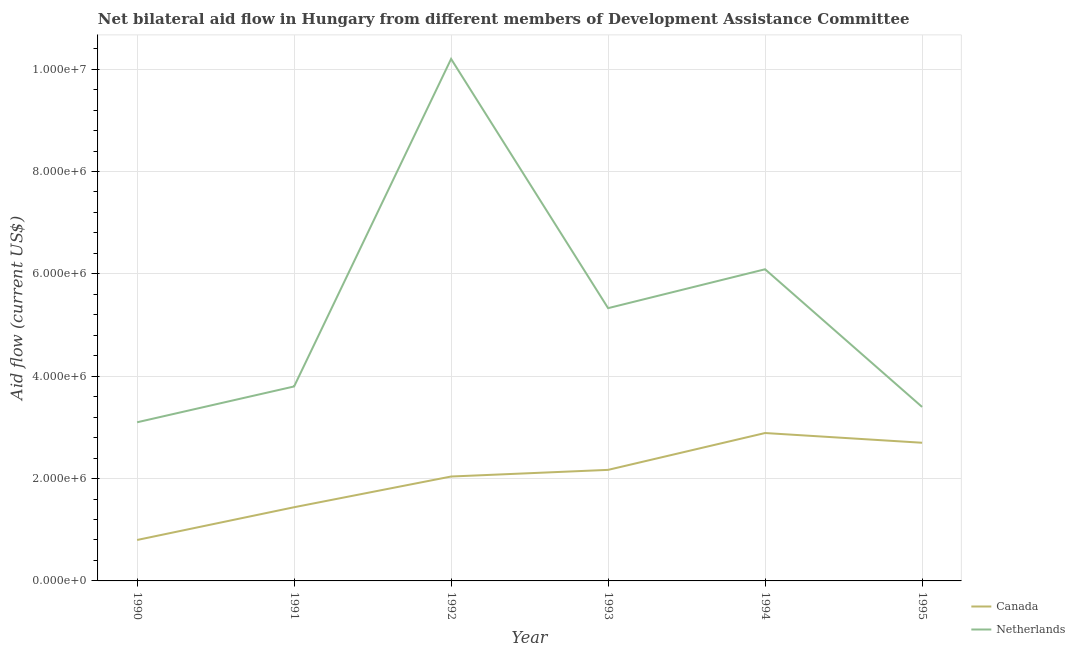How many different coloured lines are there?
Provide a succinct answer. 2. Does the line corresponding to amount of aid given by netherlands intersect with the line corresponding to amount of aid given by canada?
Your answer should be compact. No. Is the number of lines equal to the number of legend labels?
Your answer should be very brief. Yes. What is the amount of aid given by canada in 1995?
Your answer should be compact. 2.70e+06. Across all years, what is the maximum amount of aid given by netherlands?
Provide a succinct answer. 1.02e+07. Across all years, what is the minimum amount of aid given by canada?
Provide a short and direct response. 8.00e+05. In which year was the amount of aid given by canada minimum?
Your answer should be compact. 1990. What is the total amount of aid given by canada in the graph?
Offer a very short reply. 1.20e+07. What is the difference between the amount of aid given by netherlands in 1993 and that in 1994?
Offer a terse response. -7.60e+05. What is the difference between the amount of aid given by canada in 1994 and the amount of aid given by netherlands in 1990?
Keep it short and to the point. -2.10e+05. What is the average amount of aid given by netherlands per year?
Your answer should be very brief. 5.32e+06. In the year 1993, what is the difference between the amount of aid given by netherlands and amount of aid given by canada?
Give a very brief answer. 3.16e+06. What is the ratio of the amount of aid given by canada in 1991 to that in 1995?
Offer a very short reply. 0.53. Is the amount of aid given by canada in 1991 less than that in 1992?
Your response must be concise. Yes. Is the difference between the amount of aid given by canada in 1994 and 1995 greater than the difference between the amount of aid given by netherlands in 1994 and 1995?
Give a very brief answer. No. What is the difference between the highest and the second highest amount of aid given by canada?
Offer a terse response. 1.90e+05. What is the difference between the highest and the lowest amount of aid given by netherlands?
Make the answer very short. 7.10e+06. In how many years, is the amount of aid given by netherlands greater than the average amount of aid given by netherlands taken over all years?
Your answer should be compact. 3. Does the amount of aid given by netherlands monotonically increase over the years?
Ensure brevity in your answer.  No. How many years are there in the graph?
Your response must be concise. 6. Are the values on the major ticks of Y-axis written in scientific E-notation?
Provide a short and direct response. Yes. Where does the legend appear in the graph?
Your answer should be very brief. Bottom right. How are the legend labels stacked?
Make the answer very short. Vertical. What is the title of the graph?
Ensure brevity in your answer.  Net bilateral aid flow in Hungary from different members of Development Assistance Committee. What is the label or title of the Y-axis?
Offer a terse response. Aid flow (current US$). What is the Aid flow (current US$) of Netherlands in 1990?
Your answer should be very brief. 3.10e+06. What is the Aid flow (current US$) of Canada in 1991?
Ensure brevity in your answer.  1.44e+06. What is the Aid flow (current US$) of Netherlands in 1991?
Your answer should be very brief. 3.80e+06. What is the Aid flow (current US$) in Canada in 1992?
Provide a short and direct response. 2.04e+06. What is the Aid flow (current US$) of Netherlands in 1992?
Your answer should be very brief. 1.02e+07. What is the Aid flow (current US$) in Canada in 1993?
Your answer should be compact. 2.17e+06. What is the Aid flow (current US$) in Netherlands in 1993?
Offer a very short reply. 5.33e+06. What is the Aid flow (current US$) in Canada in 1994?
Offer a very short reply. 2.89e+06. What is the Aid flow (current US$) of Netherlands in 1994?
Provide a succinct answer. 6.09e+06. What is the Aid flow (current US$) of Canada in 1995?
Provide a succinct answer. 2.70e+06. What is the Aid flow (current US$) in Netherlands in 1995?
Your answer should be compact. 3.40e+06. Across all years, what is the maximum Aid flow (current US$) of Canada?
Give a very brief answer. 2.89e+06. Across all years, what is the maximum Aid flow (current US$) of Netherlands?
Your answer should be very brief. 1.02e+07. Across all years, what is the minimum Aid flow (current US$) of Netherlands?
Offer a terse response. 3.10e+06. What is the total Aid flow (current US$) of Canada in the graph?
Give a very brief answer. 1.20e+07. What is the total Aid flow (current US$) in Netherlands in the graph?
Your answer should be very brief. 3.19e+07. What is the difference between the Aid flow (current US$) in Canada in 1990 and that in 1991?
Provide a succinct answer. -6.40e+05. What is the difference between the Aid flow (current US$) of Netherlands in 1990 and that in 1991?
Provide a short and direct response. -7.00e+05. What is the difference between the Aid flow (current US$) of Canada in 1990 and that in 1992?
Provide a short and direct response. -1.24e+06. What is the difference between the Aid flow (current US$) in Netherlands in 1990 and that in 1992?
Ensure brevity in your answer.  -7.10e+06. What is the difference between the Aid flow (current US$) in Canada in 1990 and that in 1993?
Your response must be concise. -1.37e+06. What is the difference between the Aid flow (current US$) of Netherlands in 1990 and that in 1993?
Your answer should be compact. -2.23e+06. What is the difference between the Aid flow (current US$) in Canada in 1990 and that in 1994?
Your answer should be very brief. -2.09e+06. What is the difference between the Aid flow (current US$) in Netherlands in 1990 and that in 1994?
Provide a succinct answer. -2.99e+06. What is the difference between the Aid flow (current US$) of Canada in 1990 and that in 1995?
Offer a very short reply. -1.90e+06. What is the difference between the Aid flow (current US$) in Canada in 1991 and that in 1992?
Your answer should be very brief. -6.00e+05. What is the difference between the Aid flow (current US$) of Netherlands in 1991 and that in 1992?
Your answer should be very brief. -6.40e+06. What is the difference between the Aid flow (current US$) in Canada in 1991 and that in 1993?
Keep it short and to the point. -7.30e+05. What is the difference between the Aid flow (current US$) of Netherlands in 1991 and that in 1993?
Offer a terse response. -1.53e+06. What is the difference between the Aid flow (current US$) in Canada in 1991 and that in 1994?
Keep it short and to the point. -1.45e+06. What is the difference between the Aid flow (current US$) in Netherlands in 1991 and that in 1994?
Keep it short and to the point. -2.29e+06. What is the difference between the Aid flow (current US$) in Canada in 1991 and that in 1995?
Your answer should be compact. -1.26e+06. What is the difference between the Aid flow (current US$) of Netherlands in 1992 and that in 1993?
Provide a short and direct response. 4.87e+06. What is the difference between the Aid flow (current US$) of Canada in 1992 and that in 1994?
Provide a short and direct response. -8.50e+05. What is the difference between the Aid flow (current US$) of Netherlands in 1992 and that in 1994?
Your answer should be very brief. 4.11e+06. What is the difference between the Aid flow (current US$) of Canada in 1992 and that in 1995?
Keep it short and to the point. -6.60e+05. What is the difference between the Aid flow (current US$) in Netherlands in 1992 and that in 1995?
Offer a terse response. 6.80e+06. What is the difference between the Aid flow (current US$) of Canada in 1993 and that in 1994?
Provide a succinct answer. -7.20e+05. What is the difference between the Aid flow (current US$) in Netherlands in 1993 and that in 1994?
Ensure brevity in your answer.  -7.60e+05. What is the difference between the Aid flow (current US$) in Canada in 1993 and that in 1995?
Your answer should be compact. -5.30e+05. What is the difference between the Aid flow (current US$) in Netherlands in 1993 and that in 1995?
Provide a short and direct response. 1.93e+06. What is the difference between the Aid flow (current US$) of Canada in 1994 and that in 1995?
Provide a short and direct response. 1.90e+05. What is the difference between the Aid flow (current US$) in Netherlands in 1994 and that in 1995?
Ensure brevity in your answer.  2.69e+06. What is the difference between the Aid flow (current US$) of Canada in 1990 and the Aid flow (current US$) of Netherlands in 1992?
Provide a short and direct response. -9.40e+06. What is the difference between the Aid flow (current US$) of Canada in 1990 and the Aid flow (current US$) of Netherlands in 1993?
Provide a succinct answer. -4.53e+06. What is the difference between the Aid flow (current US$) in Canada in 1990 and the Aid flow (current US$) in Netherlands in 1994?
Your answer should be compact. -5.29e+06. What is the difference between the Aid flow (current US$) in Canada in 1990 and the Aid flow (current US$) in Netherlands in 1995?
Provide a short and direct response. -2.60e+06. What is the difference between the Aid flow (current US$) of Canada in 1991 and the Aid flow (current US$) of Netherlands in 1992?
Your answer should be compact. -8.76e+06. What is the difference between the Aid flow (current US$) of Canada in 1991 and the Aid flow (current US$) of Netherlands in 1993?
Make the answer very short. -3.89e+06. What is the difference between the Aid flow (current US$) of Canada in 1991 and the Aid flow (current US$) of Netherlands in 1994?
Your answer should be very brief. -4.65e+06. What is the difference between the Aid flow (current US$) of Canada in 1991 and the Aid flow (current US$) of Netherlands in 1995?
Ensure brevity in your answer.  -1.96e+06. What is the difference between the Aid flow (current US$) in Canada in 1992 and the Aid flow (current US$) in Netherlands in 1993?
Ensure brevity in your answer.  -3.29e+06. What is the difference between the Aid flow (current US$) of Canada in 1992 and the Aid flow (current US$) of Netherlands in 1994?
Provide a short and direct response. -4.05e+06. What is the difference between the Aid flow (current US$) in Canada in 1992 and the Aid flow (current US$) in Netherlands in 1995?
Ensure brevity in your answer.  -1.36e+06. What is the difference between the Aid flow (current US$) in Canada in 1993 and the Aid flow (current US$) in Netherlands in 1994?
Provide a short and direct response. -3.92e+06. What is the difference between the Aid flow (current US$) in Canada in 1993 and the Aid flow (current US$) in Netherlands in 1995?
Your answer should be compact. -1.23e+06. What is the difference between the Aid flow (current US$) of Canada in 1994 and the Aid flow (current US$) of Netherlands in 1995?
Your answer should be very brief. -5.10e+05. What is the average Aid flow (current US$) of Canada per year?
Your answer should be very brief. 2.01e+06. What is the average Aid flow (current US$) in Netherlands per year?
Make the answer very short. 5.32e+06. In the year 1990, what is the difference between the Aid flow (current US$) in Canada and Aid flow (current US$) in Netherlands?
Keep it short and to the point. -2.30e+06. In the year 1991, what is the difference between the Aid flow (current US$) in Canada and Aid flow (current US$) in Netherlands?
Keep it short and to the point. -2.36e+06. In the year 1992, what is the difference between the Aid flow (current US$) in Canada and Aid flow (current US$) in Netherlands?
Offer a terse response. -8.16e+06. In the year 1993, what is the difference between the Aid flow (current US$) of Canada and Aid flow (current US$) of Netherlands?
Provide a succinct answer. -3.16e+06. In the year 1994, what is the difference between the Aid flow (current US$) in Canada and Aid flow (current US$) in Netherlands?
Provide a succinct answer. -3.20e+06. In the year 1995, what is the difference between the Aid flow (current US$) of Canada and Aid flow (current US$) of Netherlands?
Offer a very short reply. -7.00e+05. What is the ratio of the Aid flow (current US$) in Canada in 1990 to that in 1991?
Your answer should be compact. 0.56. What is the ratio of the Aid flow (current US$) in Netherlands in 1990 to that in 1991?
Provide a short and direct response. 0.82. What is the ratio of the Aid flow (current US$) of Canada in 1990 to that in 1992?
Provide a short and direct response. 0.39. What is the ratio of the Aid flow (current US$) in Netherlands in 1990 to that in 1992?
Offer a very short reply. 0.3. What is the ratio of the Aid flow (current US$) of Canada in 1990 to that in 1993?
Your answer should be very brief. 0.37. What is the ratio of the Aid flow (current US$) in Netherlands in 1990 to that in 1993?
Your answer should be compact. 0.58. What is the ratio of the Aid flow (current US$) in Canada in 1990 to that in 1994?
Ensure brevity in your answer.  0.28. What is the ratio of the Aid flow (current US$) in Netherlands in 1990 to that in 1994?
Make the answer very short. 0.51. What is the ratio of the Aid flow (current US$) of Canada in 1990 to that in 1995?
Your answer should be compact. 0.3. What is the ratio of the Aid flow (current US$) of Netherlands in 1990 to that in 1995?
Provide a succinct answer. 0.91. What is the ratio of the Aid flow (current US$) of Canada in 1991 to that in 1992?
Offer a terse response. 0.71. What is the ratio of the Aid flow (current US$) of Netherlands in 1991 to that in 1992?
Offer a very short reply. 0.37. What is the ratio of the Aid flow (current US$) in Canada in 1991 to that in 1993?
Make the answer very short. 0.66. What is the ratio of the Aid flow (current US$) in Netherlands in 1991 to that in 1993?
Offer a terse response. 0.71. What is the ratio of the Aid flow (current US$) of Canada in 1991 to that in 1994?
Offer a terse response. 0.5. What is the ratio of the Aid flow (current US$) of Netherlands in 1991 to that in 1994?
Ensure brevity in your answer.  0.62. What is the ratio of the Aid flow (current US$) in Canada in 1991 to that in 1995?
Offer a terse response. 0.53. What is the ratio of the Aid flow (current US$) of Netherlands in 1991 to that in 1995?
Ensure brevity in your answer.  1.12. What is the ratio of the Aid flow (current US$) in Canada in 1992 to that in 1993?
Ensure brevity in your answer.  0.94. What is the ratio of the Aid flow (current US$) of Netherlands in 1992 to that in 1993?
Give a very brief answer. 1.91. What is the ratio of the Aid flow (current US$) of Canada in 1992 to that in 1994?
Ensure brevity in your answer.  0.71. What is the ratio of the Aid flow (current US$) in Netherlands in 1992 to that in 1994?
Offer a very short reply. 1.67. What is the ratio of the Aid flow (current US$) in Canada in 1992 to that in 1995?
Your answer should be compact. 0.76. What is the ratio of the Aid flow (current US$) in Canada in 1993 to that in 1994?
Give a very brief answer. 0.75. What is the ratio of the Aid flow (current US$) of Netherlands in 1993 to that in 1994?
Offer a terse response. 0.88. What is the ratio of the Aid flow (current US$) of Canada in 1993 to that in 1995?
Your response must be concise. 0.8. What is the ratio of the Aid flow (current US$) of Netherlands in 1993 to that in 1995?
Provide a succinct answer. 1.57. What is the ratio of the Aid flow (current US$) in Canada in 1994 to that in 1995?
Offer a terse response. 1.07. What is the ratio of the Aid flow (current US$) of Netherlands in 1994 to that in 1995?
Your response must be concise. 1.79. What is the difference between the highest and the second highest Aid flow (current US$) in Netherlands?
Keep it short and to the point. 4.11e+06. What is the difference between the highest and the lowest Aid flow (current US$) in Canada?
Keep it short and to the point. 2.09e+06. What is the difference between the highest and the lowest Aid flow (current US$) in Netherlands?
Ensure brevity in your answer.  7.10e+06. 